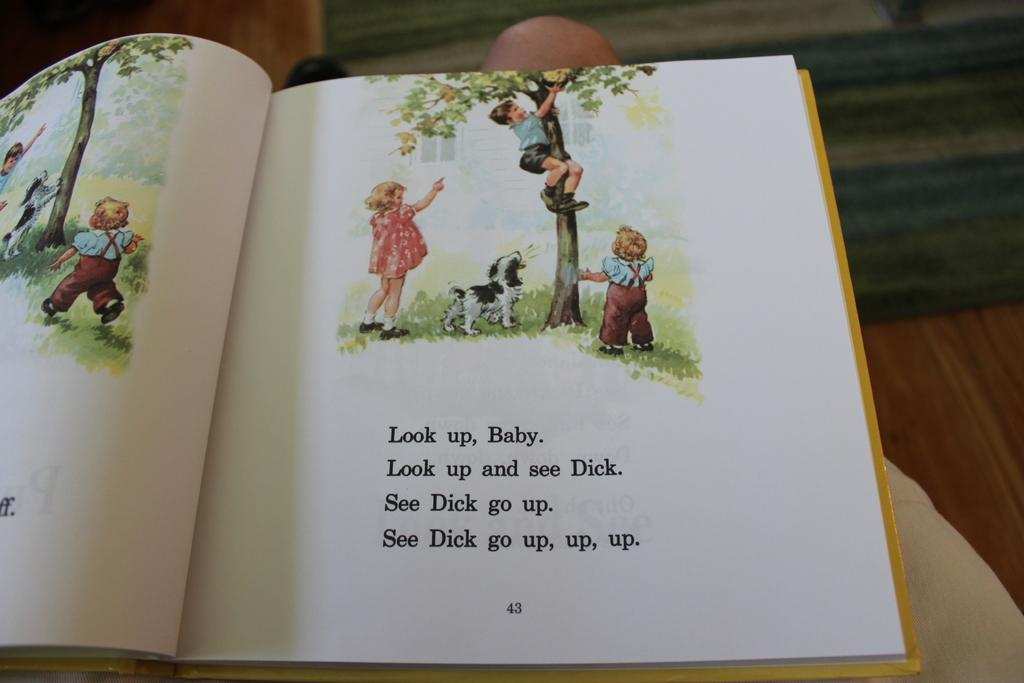<image>
Render a clear and concise summary of the photo. A book with illustrations is opened to page 43. 